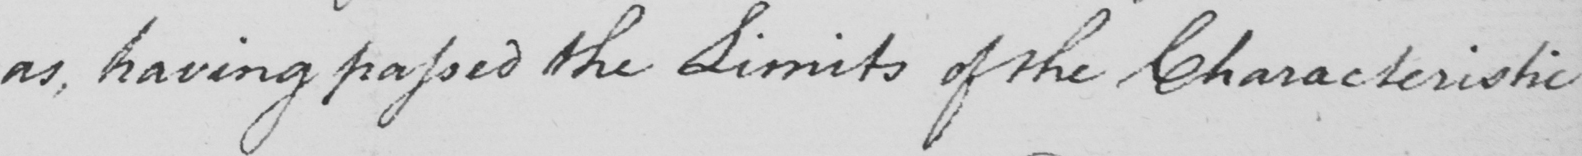Can you tell me what this handwritten text says? as , having passed the limits of the Characteristic 